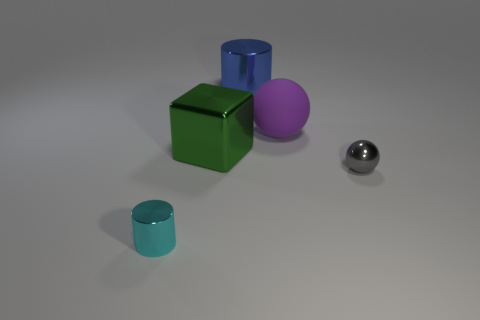Is the material of the cylinder that is in front of the big purple matte ball the same as the sphere that is in front of the purple object?
Ensure brevity in your answer.  Yes. The purple object that is the same size as the metallic cube is what shape?
Your answer should be very brief. Sphere. How many other things are there of the same color as the large ball?
Your answer should be very brief. 0. There is a big object that is in front of the purple thing; what is its color?
Your response must be concise. Green. What number of other things are made of the same material as the small gray ball?
Offer a terse response. 3. Is the number of big green objects right of the gray metallic object greater than the number of tiny gray metallic balls that are in front of the purple rubber ball?
Ensure brevity in your answer.  No. There is a big blue thing; how many metallic spheres are right of it?
Your answer should be very brief. 1. Are the big purple sphere and the tiny thing right of the big purple matte object made of the same material?
Ensure brevity in your answer.  No. Are there any other things that are the same shape as the matte thing?
Provide a short and direct response. Yes. Does the big ball have the same material as the tiny cyan object?
Offer a very short reply. No. 